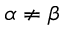Convert formula to latex. <formula><loc_0><loc_0><loc_500><loc_500>\alpha \neq \beta</formula> 